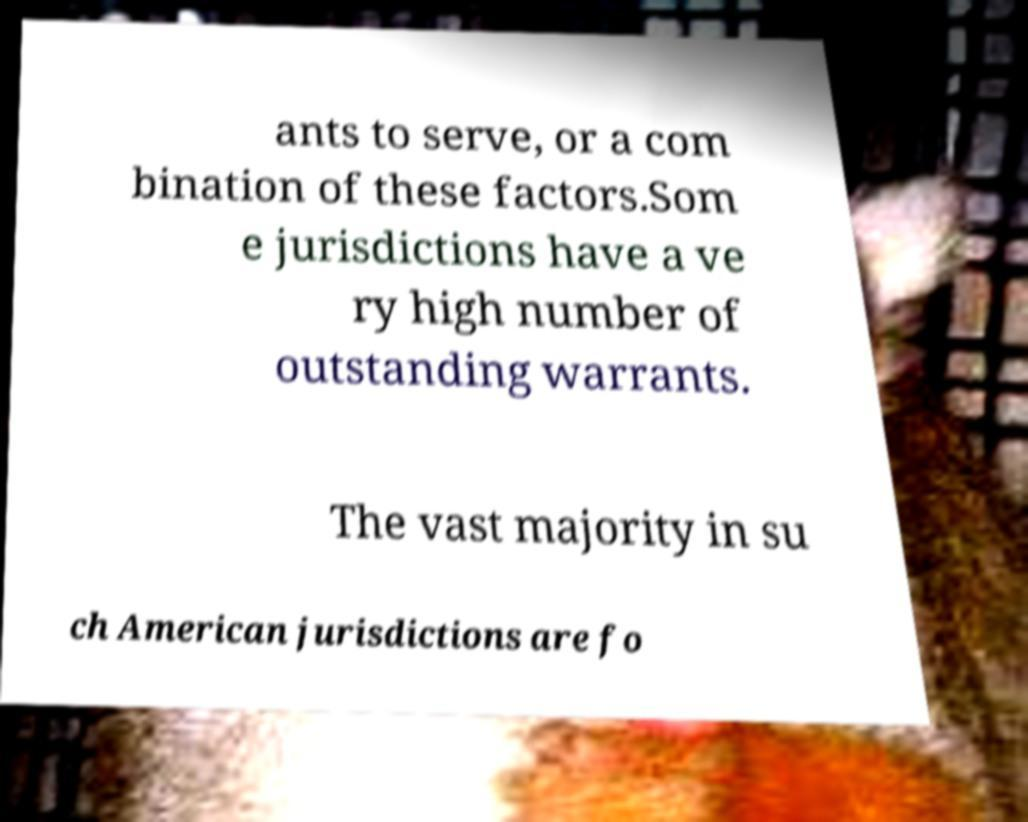Please read and relay the text visible in this image. What does it say? ants to serve, or a com bination of these factors.Som e jurisdictions have a ve ry high number of outstanding warrants. The vast majority in su ch American jurisdictions are fo 